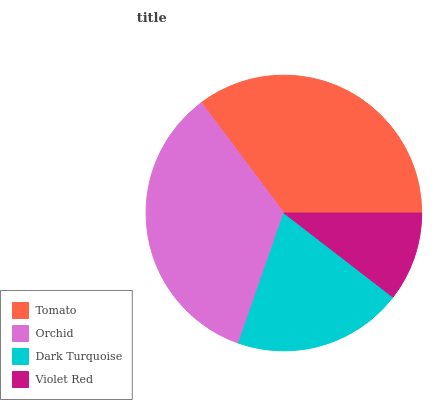Is Violet Red the minimum?
Answer yes or no. Yes. Is Tomato the maximum?
Answer yes or no. Yes. Is Orchid the minimum?
Answer yes or no. No. Is Orchid the maximum?
Answer yes or no. No. Is Tomato greater than Orchid?
Answer yes or no. Yes. Is Orchid less than Tomato?
Answer yes or no. Yes. Is Orchid greater than Tomato?
Answer yes or no. No. Is Tomato less than Orchid?
Answer yes or no. No. Is Orchid the high median?
Answer yes or no. Yes. Is Dark Turquoise the low median?
Answer yes or no. Yes. Is Dark Turquoise the high median?
Answer yes or no. No. Is Tomato the low median?
Answer yes or no. No. 